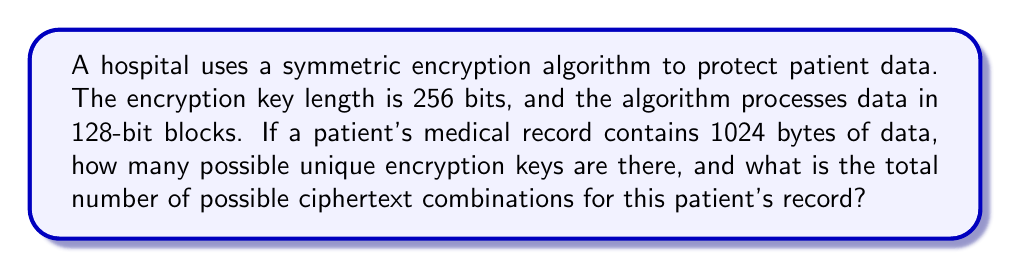Teach me how to tackle this problem. Step 1: Calculate the number of possible encryption keys
- The encryption key length is 256 bits
- Number of possible keys = $2^{256}$

Step 2: Calculate the number of 128-bit blocks in the patient's record
- Patient's record size = 1024 bytes = 1024 * 8 = 8192 bits
- Number of 128-bit blocks = $\frac{8192}{128} = 64$ blocks

Step 3: Calculate the number of possible ciphertext combinations for each block
- Each 128-bit block has $2^{128}$ possible ciphertext combinations

Step 4: Calculate the total number of possible ciphertext combinations for the entire record
- Total combinations = $(2^{128})^{64} = 2^{128 * 64} = 2^{8192}$

Step 5: Express the results in scientific notation
- Number of possible keys = $2^{256} \approx 1.16 \times 10^{77}$
- Total ciphertext combinations = $2^{8192} \approx 1.01 \times 10^{2466}$
Answer: $1.16 \times 10^{77}$ keys, $1.01 \times 10^{2466}$ ciphertext combinations 